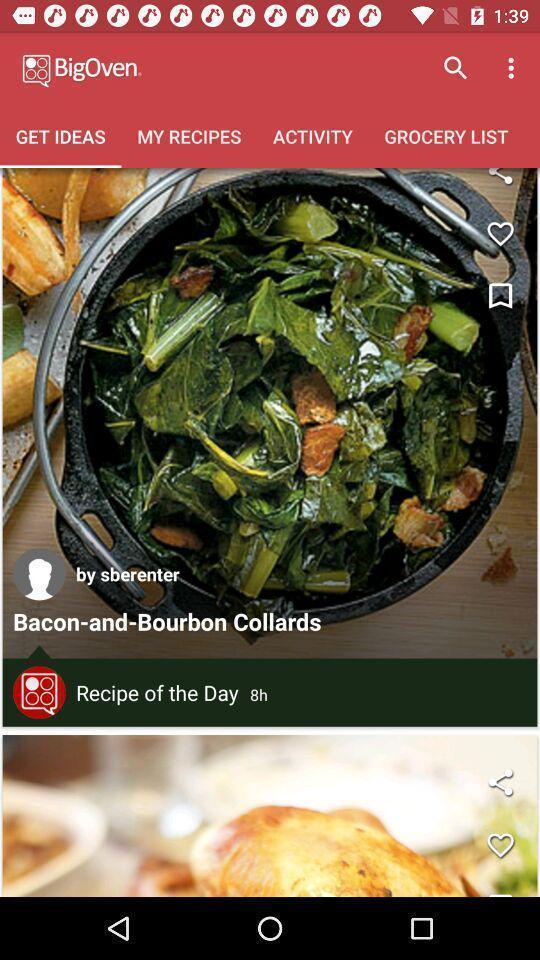Provide a detailed account of this screenshot. Page displaying with list of different recipes. 